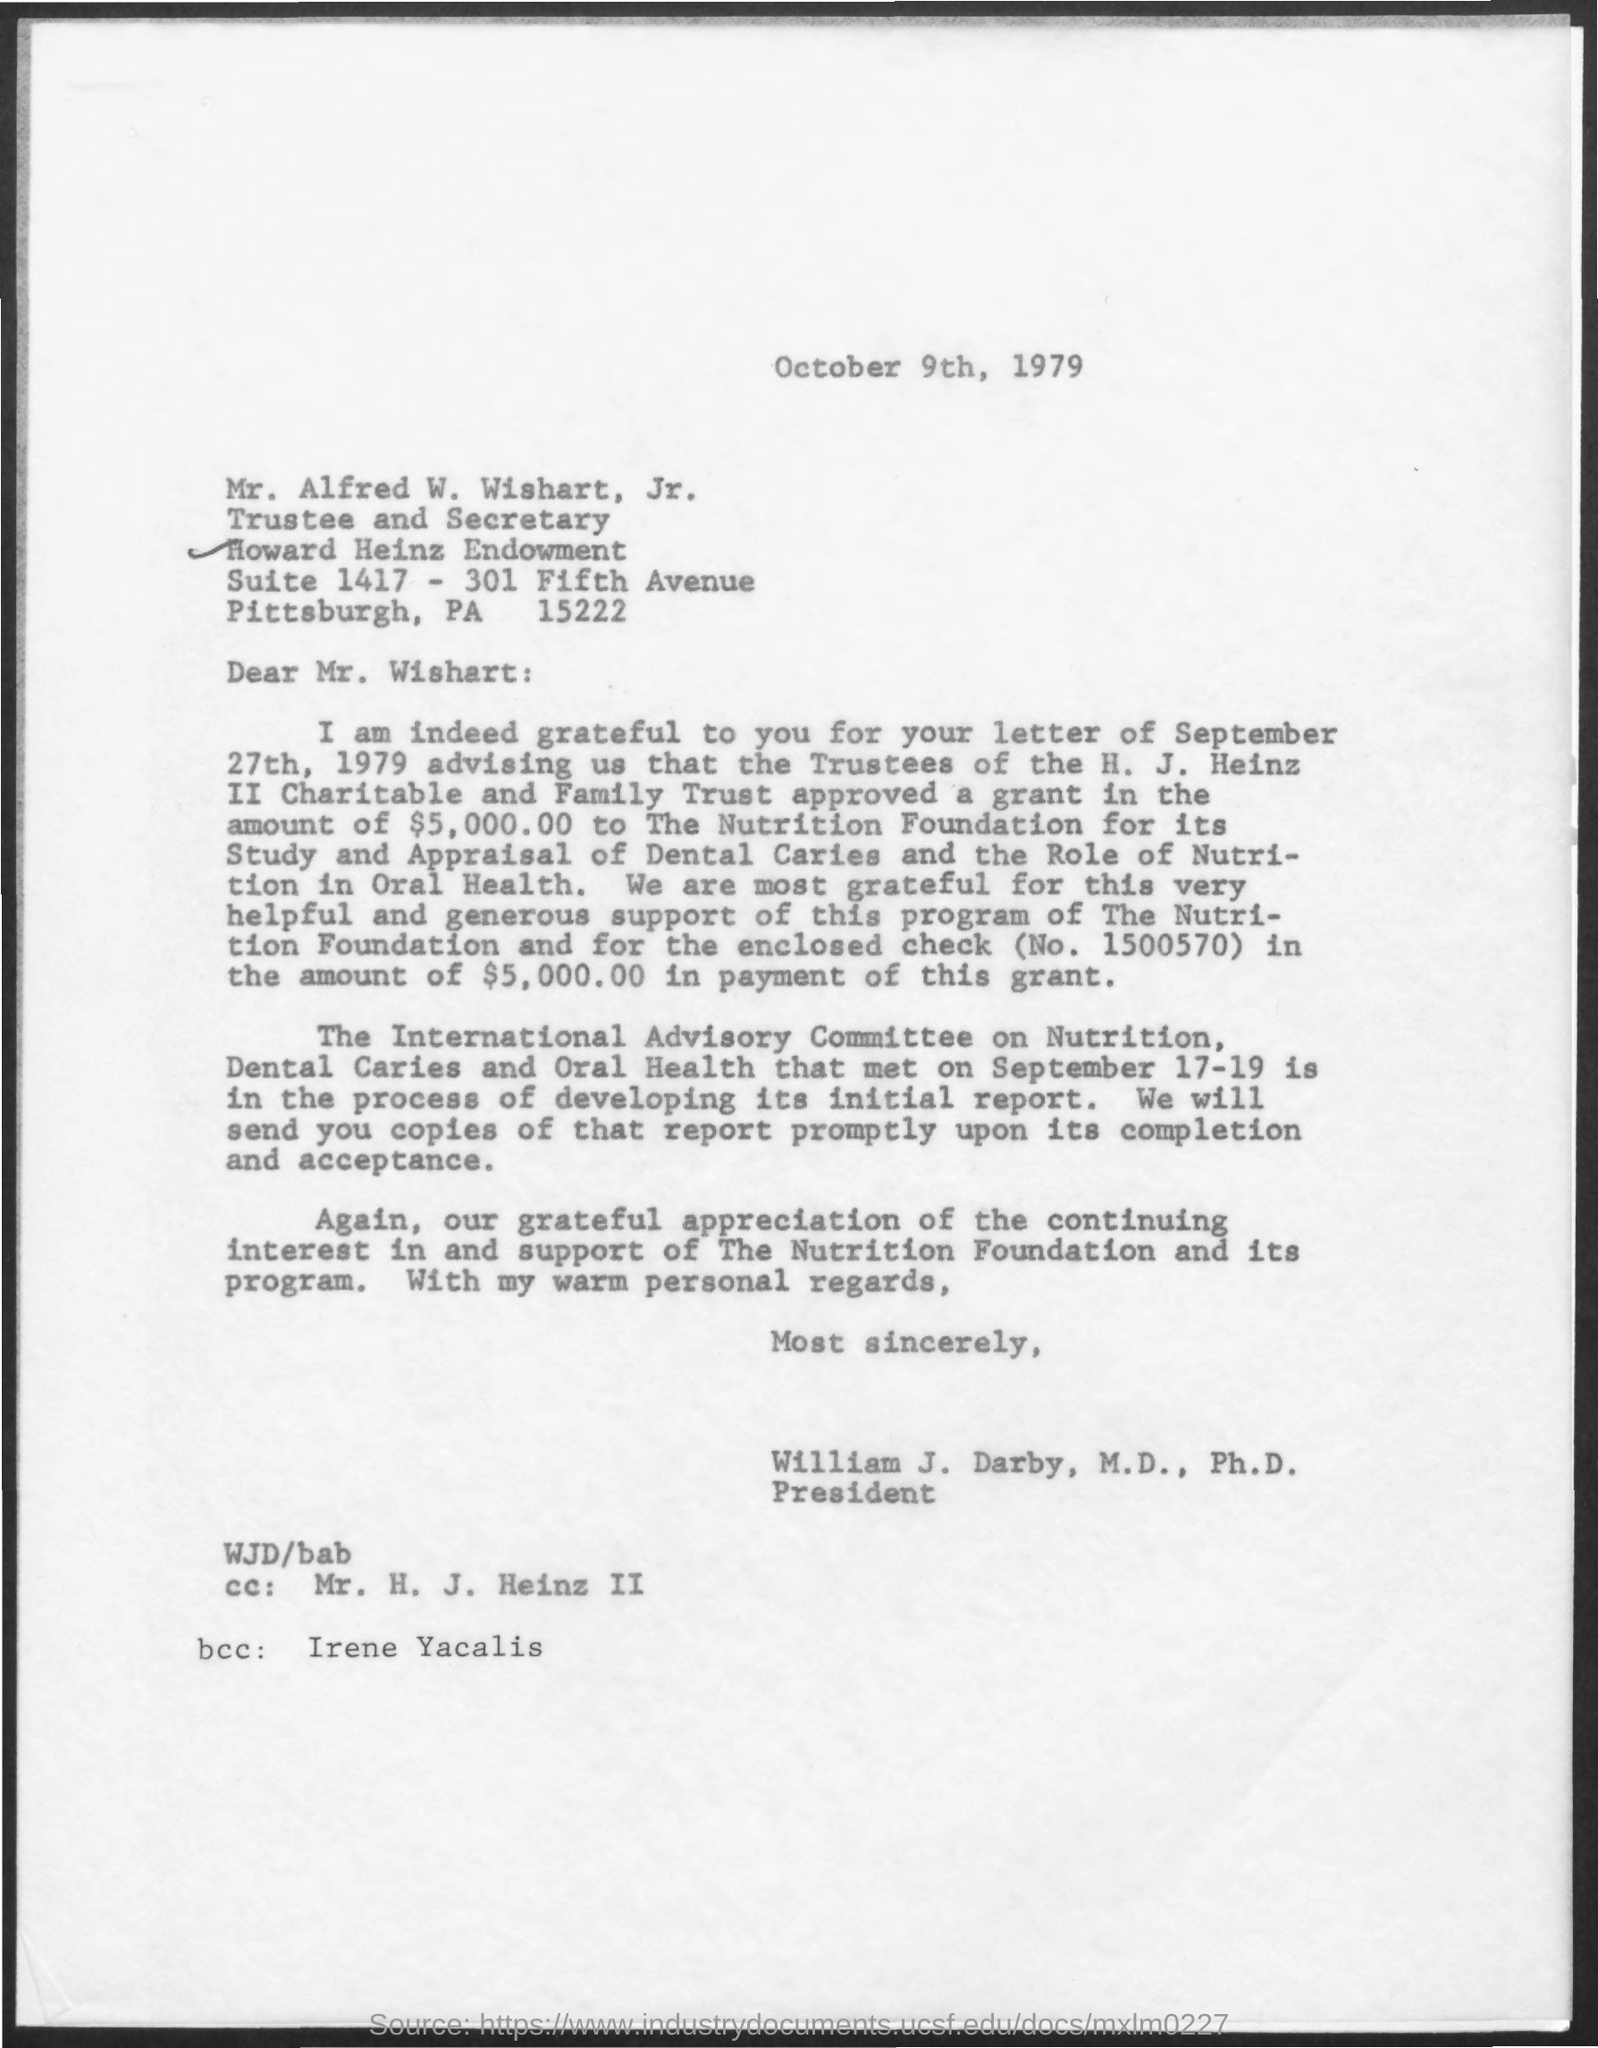When is the Memorandum dated on ?
Give a very brief answer. October 9th, 1979. Who is the CC in this letter ?
Offer a terse response. Mr. H. J. Heinz II. Who is the bcc in this letter ?
Your answer should be compact. Irene Yacalis. How much amount is written in this letter ?
Keep it short and to the point. $5,000.00. 